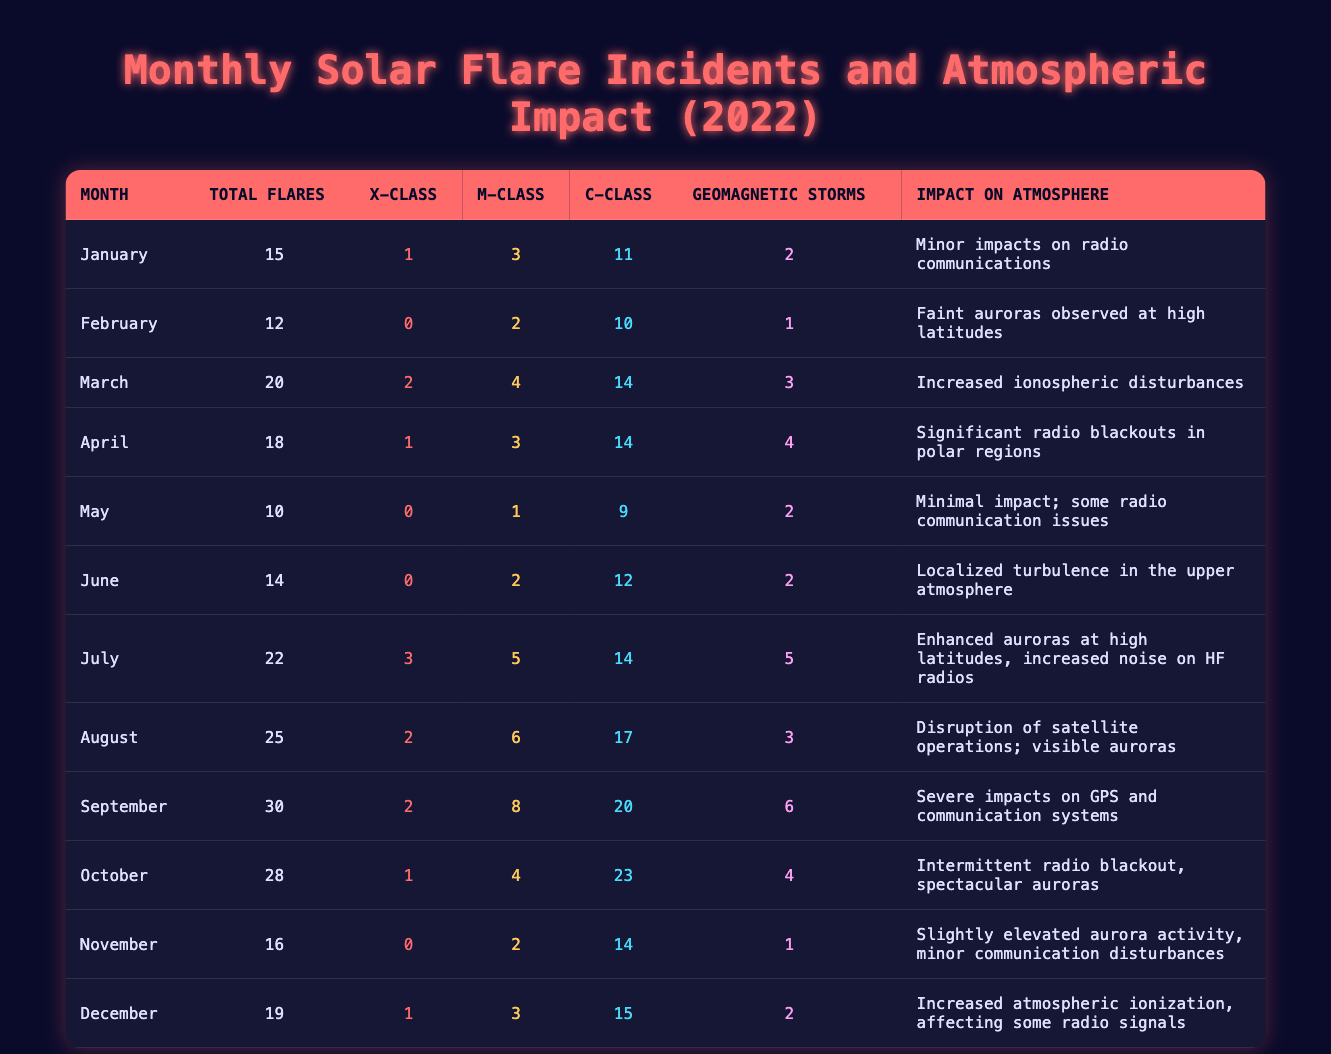What was the total number of solar flares in June? In the data for June, the total number of solar flares is directly listed in the table as 14.
Answer: 14 Which month had the highest number of geomagnetic storms? By comparing the geomagnetic storms for each month, September has the highest count with 6 storms.
Answer: September What is the impact on the atmosphere for the month with the most X-Class flares? July had the most X-Class flares (3), and the impact listed is "Enhanced auroras at high latitudes, increased noise on HF radios."
Answer: Enhanced auroras at high latitudes, increased noise on HF radios How many total flares were recorded from March to May? Adding the total number of flares in these months: March (20) + April (18) + May (10) = 48.
Answer: 48 In which month did the solar flares cause "severe impacts on GPS and communication systems"? According to the data, September is the month that caused "severe impacts on GPS and communication systems."
Answer: September Did any month record zero X-Class flares? Yes, February and May both recorded zero X-Class flares according to the table.
Answer: Yes Which month had more M-Class flares, January or November? January had 3 M-Class flares, while November had 2 M-Class flares. Therefore, January has more M-Class flares.
Answer: January What is the average number of total flares per month for the entire year? The total number of flares for all months is 15 + 12 + 20 + 18 + 10 + 14 + 22 + 25 + 30 + 28 + 16 + 19 =  19.5 per month, as there are 12 months in total.
Answer: 19.5 Was there an increase in the number of C-Class flares from April to July? April had 14 C-Class flares, while July had 14 C-Class flares; both months had the same number and therefore no increase occurred.
Answer: No 